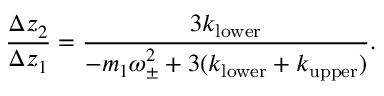<formula> <loc_0><loc_0><loc_500><loc_500>\frac { \Delta z _ { 2 } } { \Delta z _ { 1 } } = \frac { 3 k _ { l o w e r } } { - m _ { 1 } \omega _ { \pm } ^ { 2 } + 3 ( k _ { l o w e r } + k _ { u p p e r } ) } .</formula> 